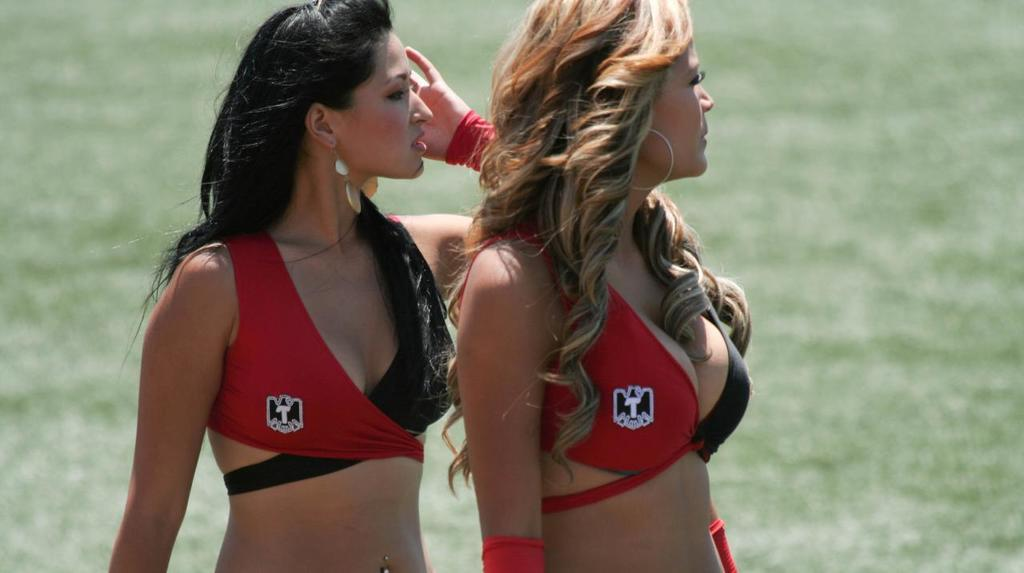<image>
Describe the image concisely. Two women wear tops that have the letter "T" on the right side. 